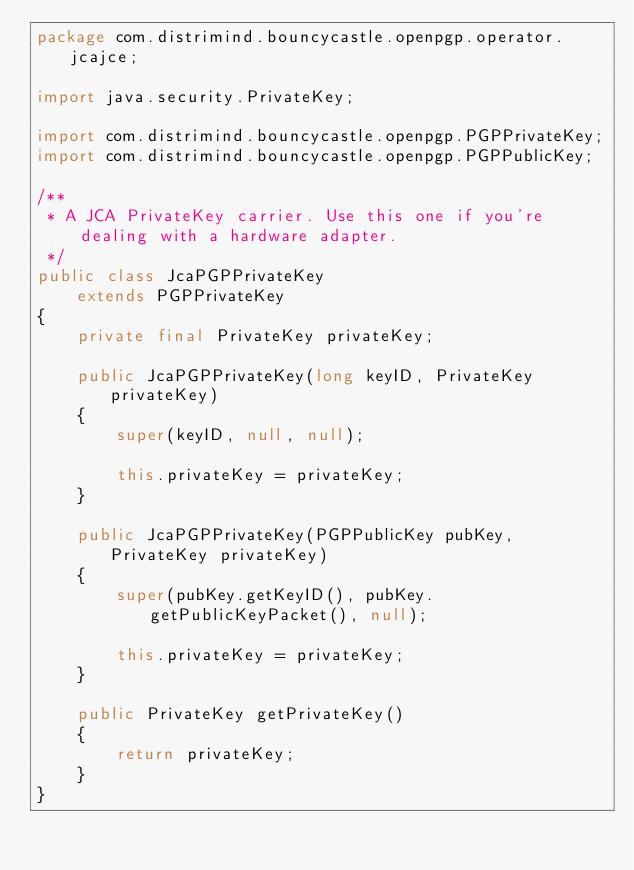Convert code to text. <code><loc_0><loc_0><loc_500><loc_500><_Java_>package com.distrimind.bouncycastle.openpgp.operator.jcajce;

import java.security.PrivateKey;

import com.distrimind.bouncycastle.openpgp.PGPPrivateKey;
import com.distrimind.bouncycastle.openpgp.PGPPublicKey;

/**
 * A JCA PrivateKey carrier. Use this one if you're dealing with a hardware adapter.
 */
public class JcaPGPPrivateKey
    extends PGPPrivateKey
{
    private final PrivateKey privateKey;

    public JcaPGPPrivateKey(long keyID, PrivateKey privateKey)
    {
        super(keyID, null, null);

        this.privateKey = privateKey;
    }

    public JcaPGPPrivateKey(PGPPublicKey pubKey, PrivateKey privateKey)
    {
        super(pubKey.getKeyID(), pubKey.getPublicKeyPacket(), null);

        this.privateKey = privateKey;
    }

    public PrivateKey getPrivateKey()
    {
        return privateKey;
    }
}
</code> 